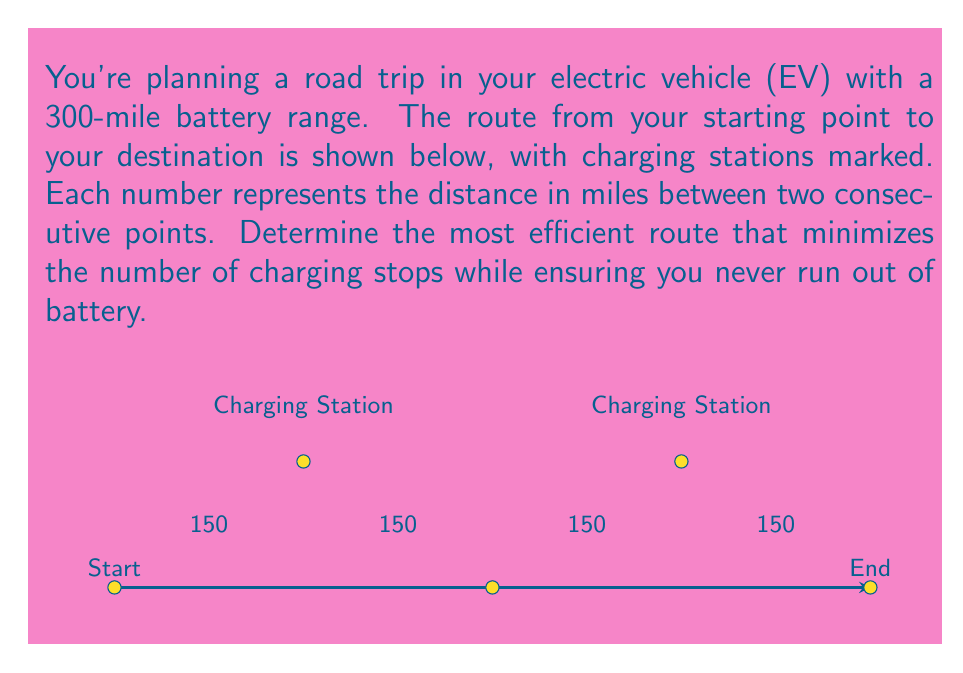Help me with this question. Let's approach this step-by-step:

1) First, we need to calculate the total distance of the trip:
   $150 + 150 + 150 + 150 = 600$ miles

2) Given that our EV has a 300-mile range, we know we'll need to charge at least once during the trip.

3) Let's consider our options:
   a) Charge at B (150 miles from start)
   b) Charge at D (450 miles from start)
   c) Charge at both B and D

4) Option a: If we charge at B, we can make it to D (300 miles) but not to the end (450 miles).

5) Option b: We can't reach D on a single charge as it's 450 miles from the start.

6) Option c: This is our only viable option. Here's how it works:
   - Start with a full charge (300 miles)
   - Drive to B (150 miles), arriving with 150 miles of range left
   - Charge at B to full capacity (300 miles)
   - Drive to D (300 miles), arriving with 0 miles of range
   - Charge at D to at least 150 miles of range
   - Drive to End (150 miles)

7) This route requires 2 charging stops (at B and D) and ensures we never run out of battery.

Therefore, the most efficient route is to stop and charge at both charging stations B and D.
Answer: Charge at stations B and D 